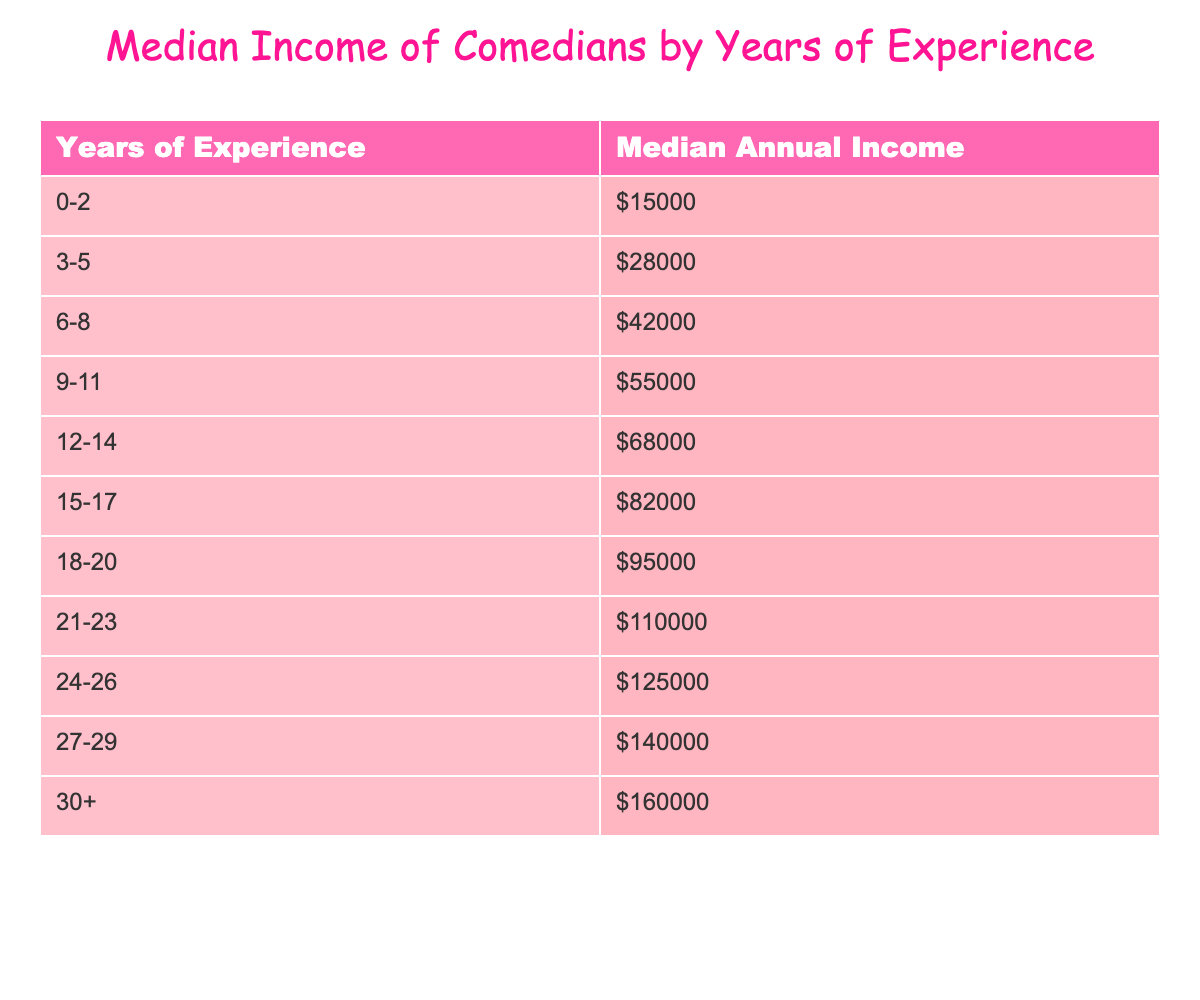What is the median annual income for comedians with 0-2 years of experience? The table shows that for the experience range of 0-2 years, the median annual income is listed directly as $15,000.
Answer: $15,000 How much do comedians with 12-14 years of experience earn? According to the table, comedians with 12-14 years of experience have a median annual income of $68,000.
Answer: $68,000 Which experience range has the highest median income? The table indicates that the highest median income is for the experience range of 30+, which is $160,000.
Answer: $160,000 What is the difference in median income between comedians with 3-5 years and those with 9-11 years of experience? The median income for comedians with 3-5 years is $28,000, and for 9-11 years it is $55,000. The difference is $55,000 - $28,000 = $27,000.
Answer: $27,000 What is the average median income of comedians who have between 3-8 years of experience? The median incomes for 3-5 and 6-8 years are $28,000 and $42,000, respectively. The average is calculated as ($28,000 + $42,000) / 2 = $35,000.
Answer: $35,000 Is the median income for comedians with 24-26 years of experience greater than that for comedians with 21-23 years of experience? The table shows a median income of $125,000 for 24-26 years compared to $110,000 for 21-23 years, indicating that yes, it is greater.
Answer: Yes What is the total median income of comedians with 27-29 years and 30+ years of experience combined? The median income for 27-29 years is $140,000 and for 30+ years is $160,000. The total is $140,000 + $160,000 = $300,000.
Answer: $300,000 How does the median income for comedians in the 18-20 years range compare to that of those with 12-14 years of experience? The median income for 18-20 years is $95,000, while for 12-14 years it is $68,000. $95,000 is greater than $68,000, indicating that 18-20 years earns more.
Answer: Yes What is the pattern of median income increase as years of experience increase? The table shows a consistent increase in median income, starting at $15,000 for 0-2 years and reaching $160,000 for 30+ years, indicating a positive correlation between experience and income.
Answer: Positive correlation 